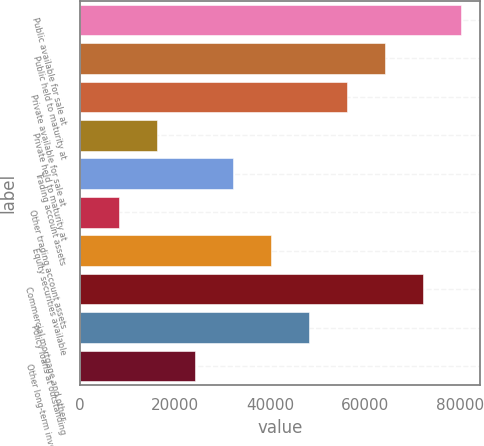Convert chart. <chart><loc_0><loc_0><loc_500><loc_500><bar_chart><fcel>Public available for sale at<fcel>Public held to maturity at<fcel>Private available for sale at<fcel>Private held to maturity at<fcel>Trading account assets<fcel>Other trading account assets<fcel>Equity securities available<fcel>Commercial mortgage and other<fcel>Policy loans at outstanding<fcel>Other long-term investments(1)<nl><fcel>80293<fcel>64276.6<fcel>56268.4<fcel>16227.4<fcel>32243.8<fcel>8219.2<fcel>40252<fcel>72284.8<fcel>48260.2<fcel>24235.6<nl></chart> 